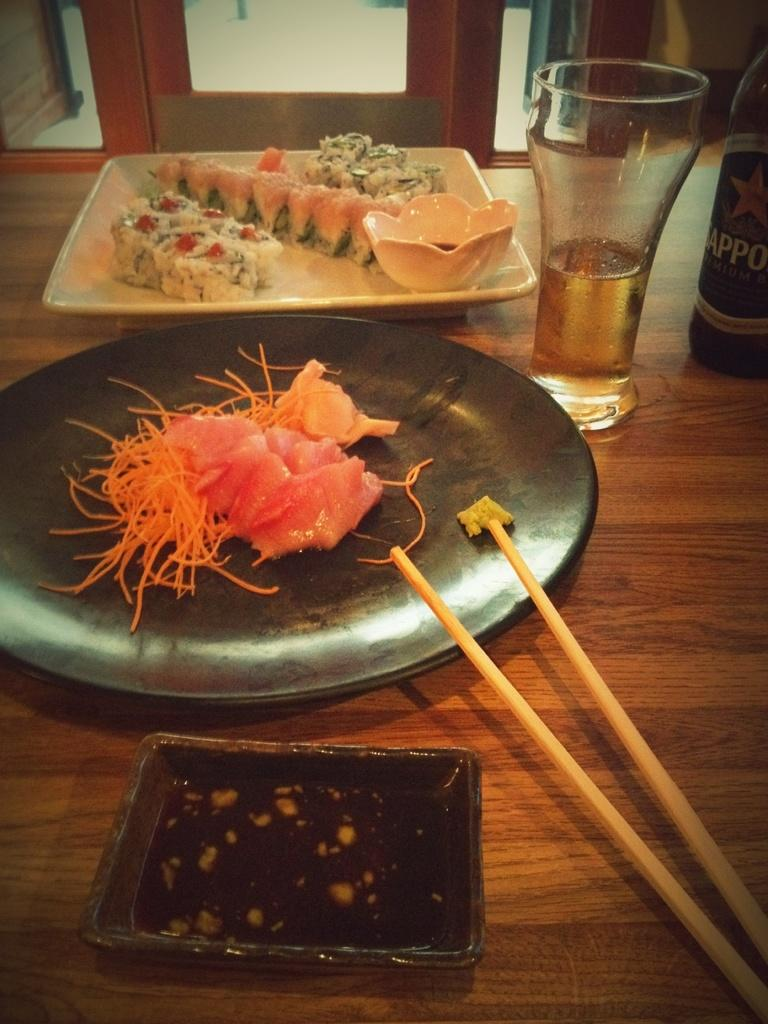What is the main object in the center of the image? There is a table in the middle of the image. What items can be found on the table? On the table, there is a plate, a glass, a bottle, and sticks. Are there any food items on the table? Yes, there are food items on the table. Can you describe anything in the background of the image? In the background, there is a glass. How many cherries are floating in the air in the image? There are no cherries visible in the image, and none are floating in the air. What is the state of the person's mind in the image? There is no person present in the image, so it is impossible to determine the state of their mind. 